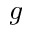<formula> <loc_0><loc_0><loc_500><loc_500>g</formula> 